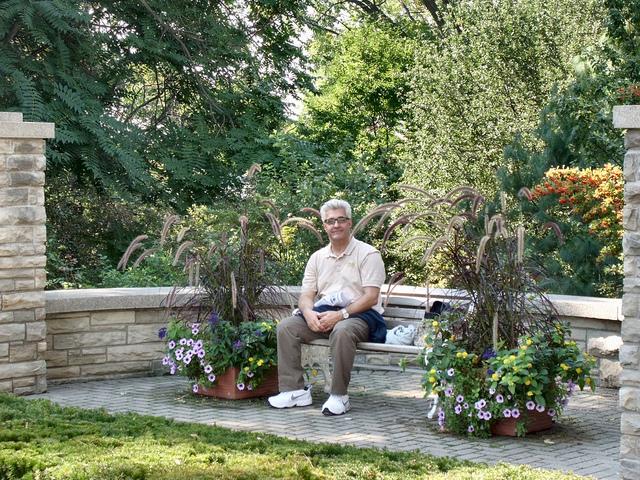What color is this man's hair?
Answer briefly. White. Where is the man staring?
Short answer required. At camera. What color is the men's jeans?
Write a very short answer. Brown. How many planters are there?
Answer briefly. 2. How many people are in the picture?
Short answer required. 1. 